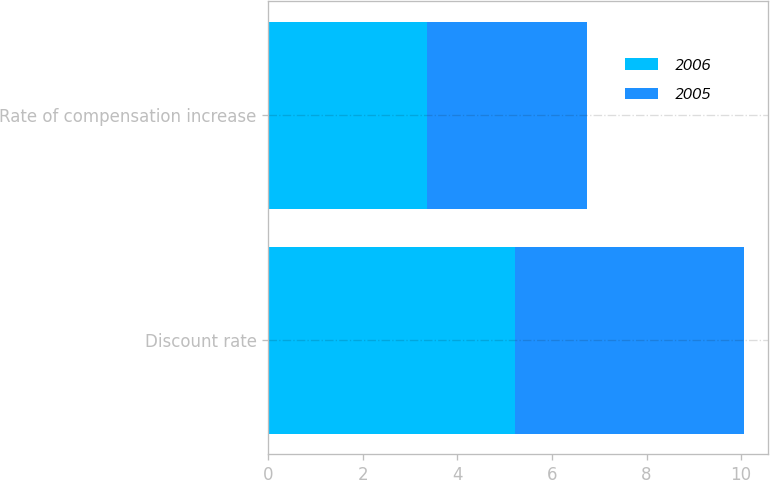Convert chart. <chart><loc_0><loc_0><loc_500><loc_500><stacked_bar_chart><ecel><fcel>Discount rate<fcel>Rate of compensation increase<nl><fcel>2006<fcel>5.21<fcel>3.35<nl><fcel>2005<fcel>4.86<fcel>3.39<nl></chart> 